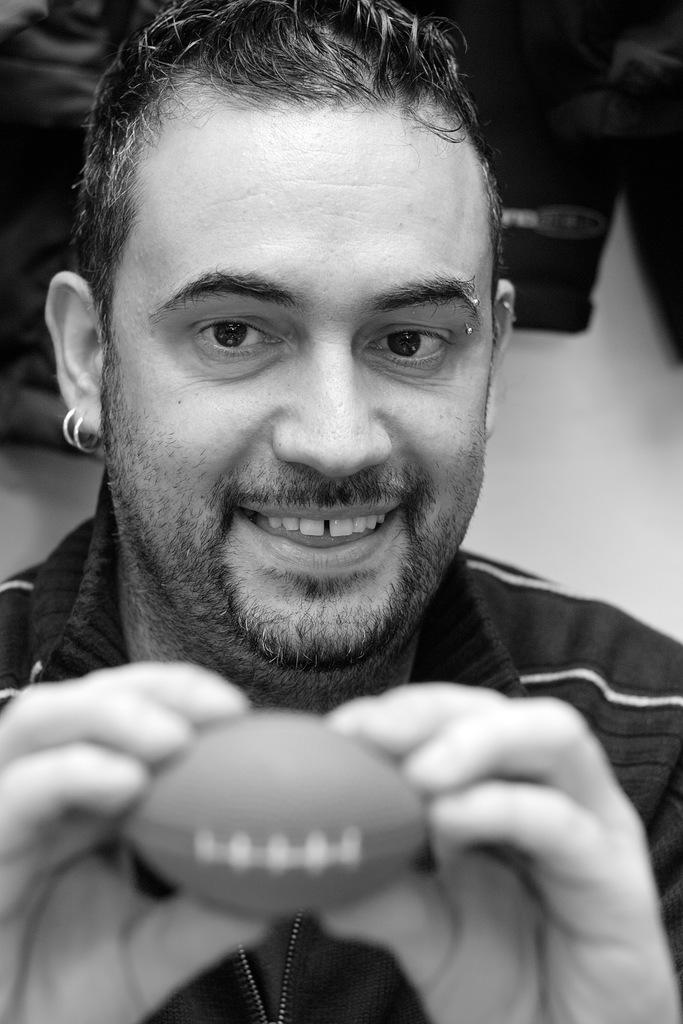What is the color scheme of the image? The image is black and white. Who is present in the image? There is a man in the image. What is the man holding in the image? The man is holding a small ball. What type of body modifications does the man have? The man has rings in his ears and a ring on his eyebrow. What type of authority does the beggar have in the image? There is no beggar present in the image, and therefore no authority can be attributed to them. 